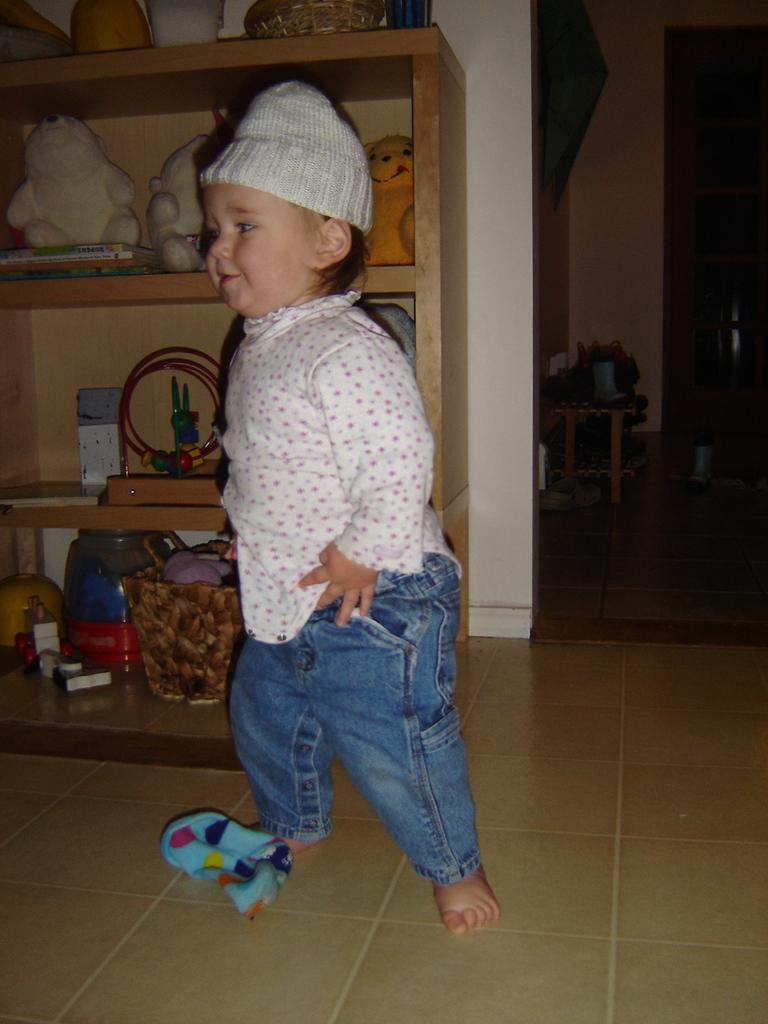Could you give a brief overview of what you see in this image? In this image I can see in the middle there is a baby standing, this baby is wearing a trouser, t-shirt and a cap. In the background there are dolls and other things on the shelves. 